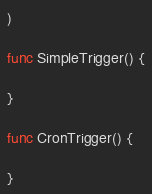<code> <loc_0><loc_0><loc_500><loc_500><_Go_>
)

func SimpleTrigger() {
	
}

func CronTrigger() {
	
}
</code> 